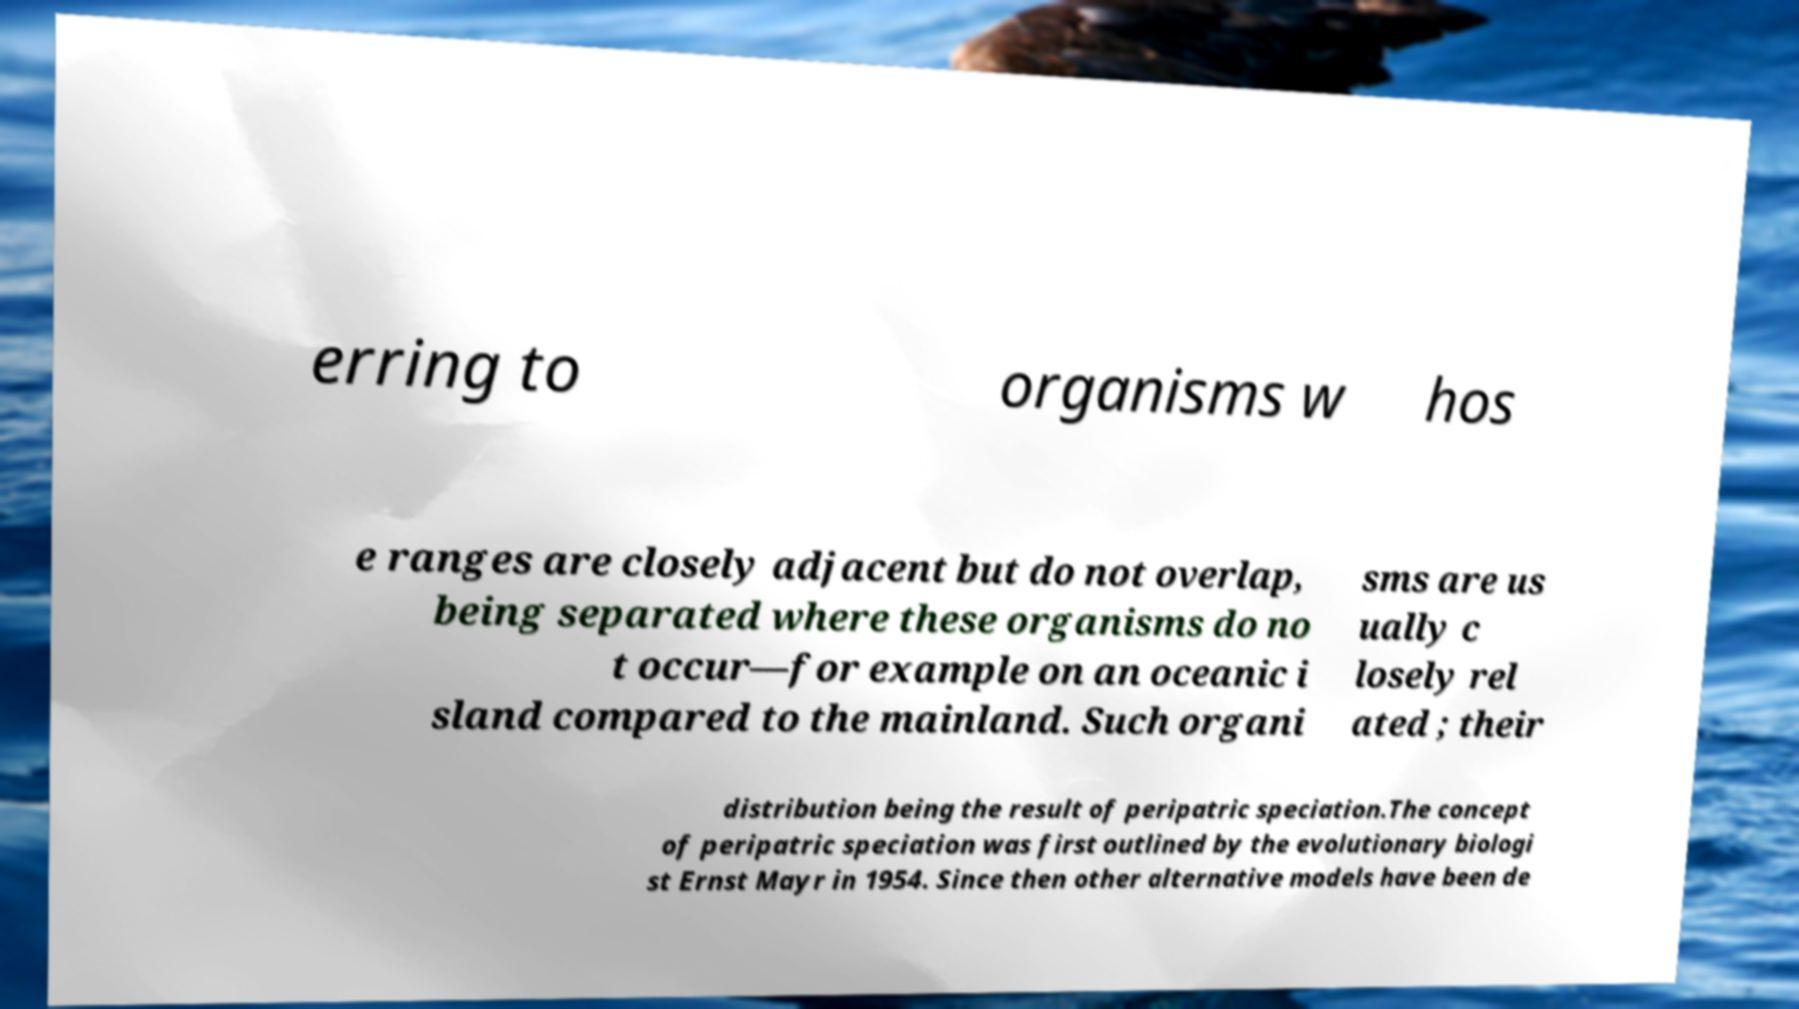Please identify and transcribe the text found in this image. erring to organisms w hos e ranges are closely adjacent but do not overlap, being separated where these organisms do no t occur—for example on an oceanic i sland compared to the mainland. Such organi sms are us ually c losely rel ated ; their distribution being the result of peripatric speciation.The concept of peripatric speciation was first outlined by the evolutionary biologi st Ernst Mayr in 1954. Since then other alternative models have been de 